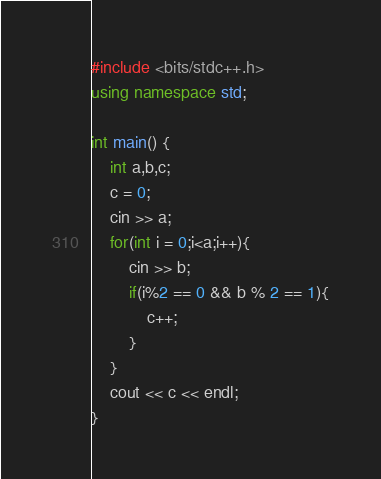Convert code to text. <code><loc_0><loc_0><loc_500><loc_500><_C++_>#include <bits/stdc++.h>
using namespace std;

int main() {
    int a,b,c;
    c = 0;
    cin >> a;
    for(int i = 0;i<a;i++){
        cin >> b;
        if(i%2 == 0 && b % 2 == 1){
            c++;
        }
    }
    cout << c << endl;
}</code> 